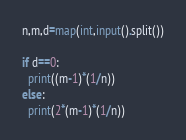<code> <loc_0><loc_0><loc_500><loc_500><_Python_>n,m,d=map(int,input().split())

if d==0:
  print((m-1)*(1/n))
else:
  print(2*(m-1)*(1/n))</code> 